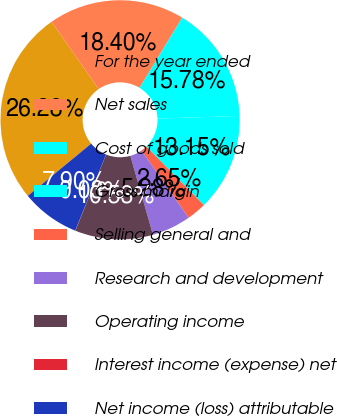<chart> <loc_0><loc_0><loc_500><loc_500><pie_chart><fcel>For the year ended<fcel>Net sales<fcel>Cost of goods sold<fcel>Gross margin<fcel>Selling general and<fcel>Research and development<fcel>Operating income<fcel>Interest income (expense) net<fcel>Net income (loss) attributable<nl><fcel>26.28%<fcel>18.4%<fcel>15.78%<fcel>13.15%<fcel>2.65%<fcel>5.28%<fcel>10.53%<fcel>0.03%<fcel>7.9%<nl></chart> 